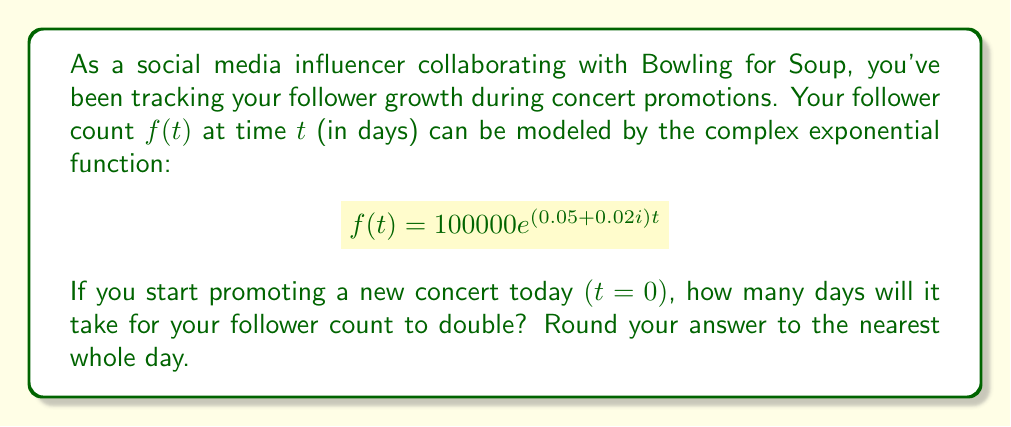Can you solve this math problem? Let's approach this step-by-step:

1) We need to find $t$ when $f(t) = 2f(0)$. This means:

   $$100000e^{(0.05+0.02i)t} = 2 \cdot 100000$$

2) Simplify:

   $$e^{(0.05+0.02i)t} = 2$$

3) Take the natural logarithm of both sides:

   $$(0.05+0.02i)t = \ln(2)$$

4) We're only interested in the real part of this equation, as that determines the magnitude. The imaginary part affects the phase but not the absolute value. So:

   $$0.05t = \ln(2)$$

5) Solve for $t$:

   $$t = \frac{\ln(2)}{0.05}$$

6) Calculate:

   $$t = \frac{0.693147...}{0.05} = 13.8629...$$

7) Rounding to the nearest whole day:

   $$t \approx 14 \text{ days}$$
Answer: 14 days 